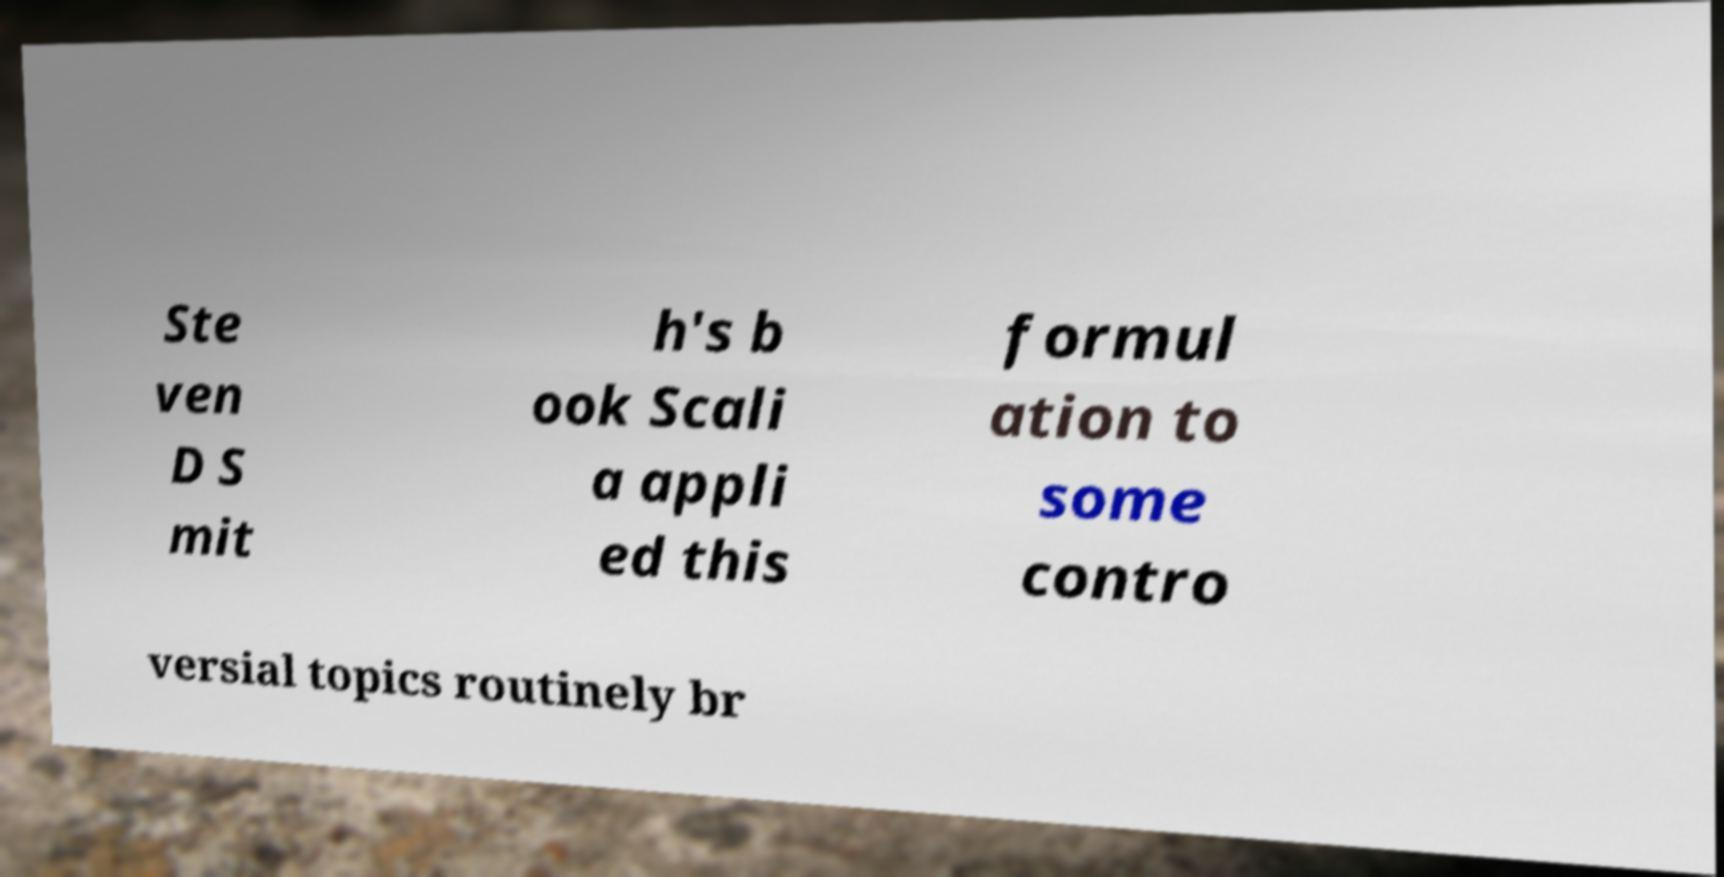Please read and relay the text visible in this image. What does it say? Ste ven D S mit h's b ook Scali a appli ed this formul ation to some contro versial topics routinely br 